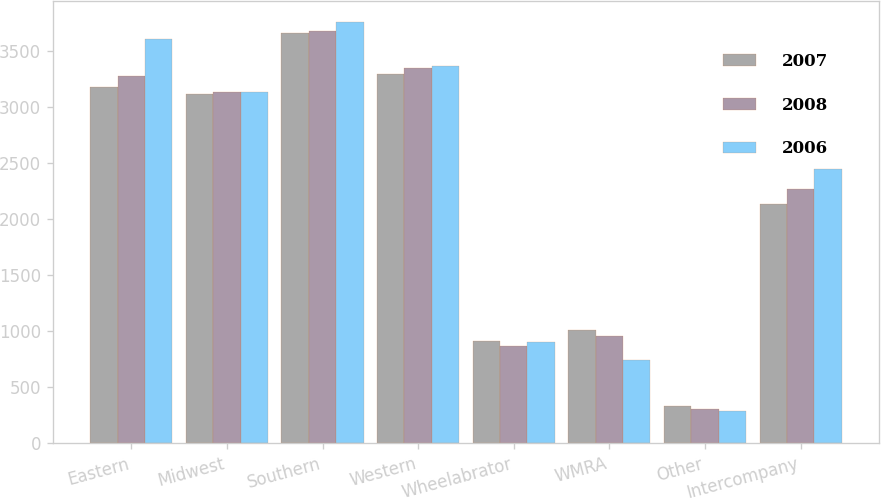Convert chart to OTSL. <chart><loc_0><loc_0><loc_500><loc_500><stacked_bar_chart><ecel><fcel>Eastern<fcel>Midwest<fcel>Southern<fcel>Western<fcel>Wheelabrator<fcel>WMRA<fcel>Other<fcel>Intercompany<nl><fcel>2007<fcel>3182<fcel>3117<fcel>3667<fcel>3300<fcel>912<fcel>1014<fcel>330<fcel>2134<nl><fcel>2008<fcel>3281<fcel>3141<fcel>3681<fcel>3350<fcel>868<fcel>953<fcel>307<fcel>2271<nl><fcel>2006<fcel>3614<fcel>3141<fcel>3759<fcel>3373<fcel>902<fcel>740<fcel>283<fcel>2449<nl></chart> 